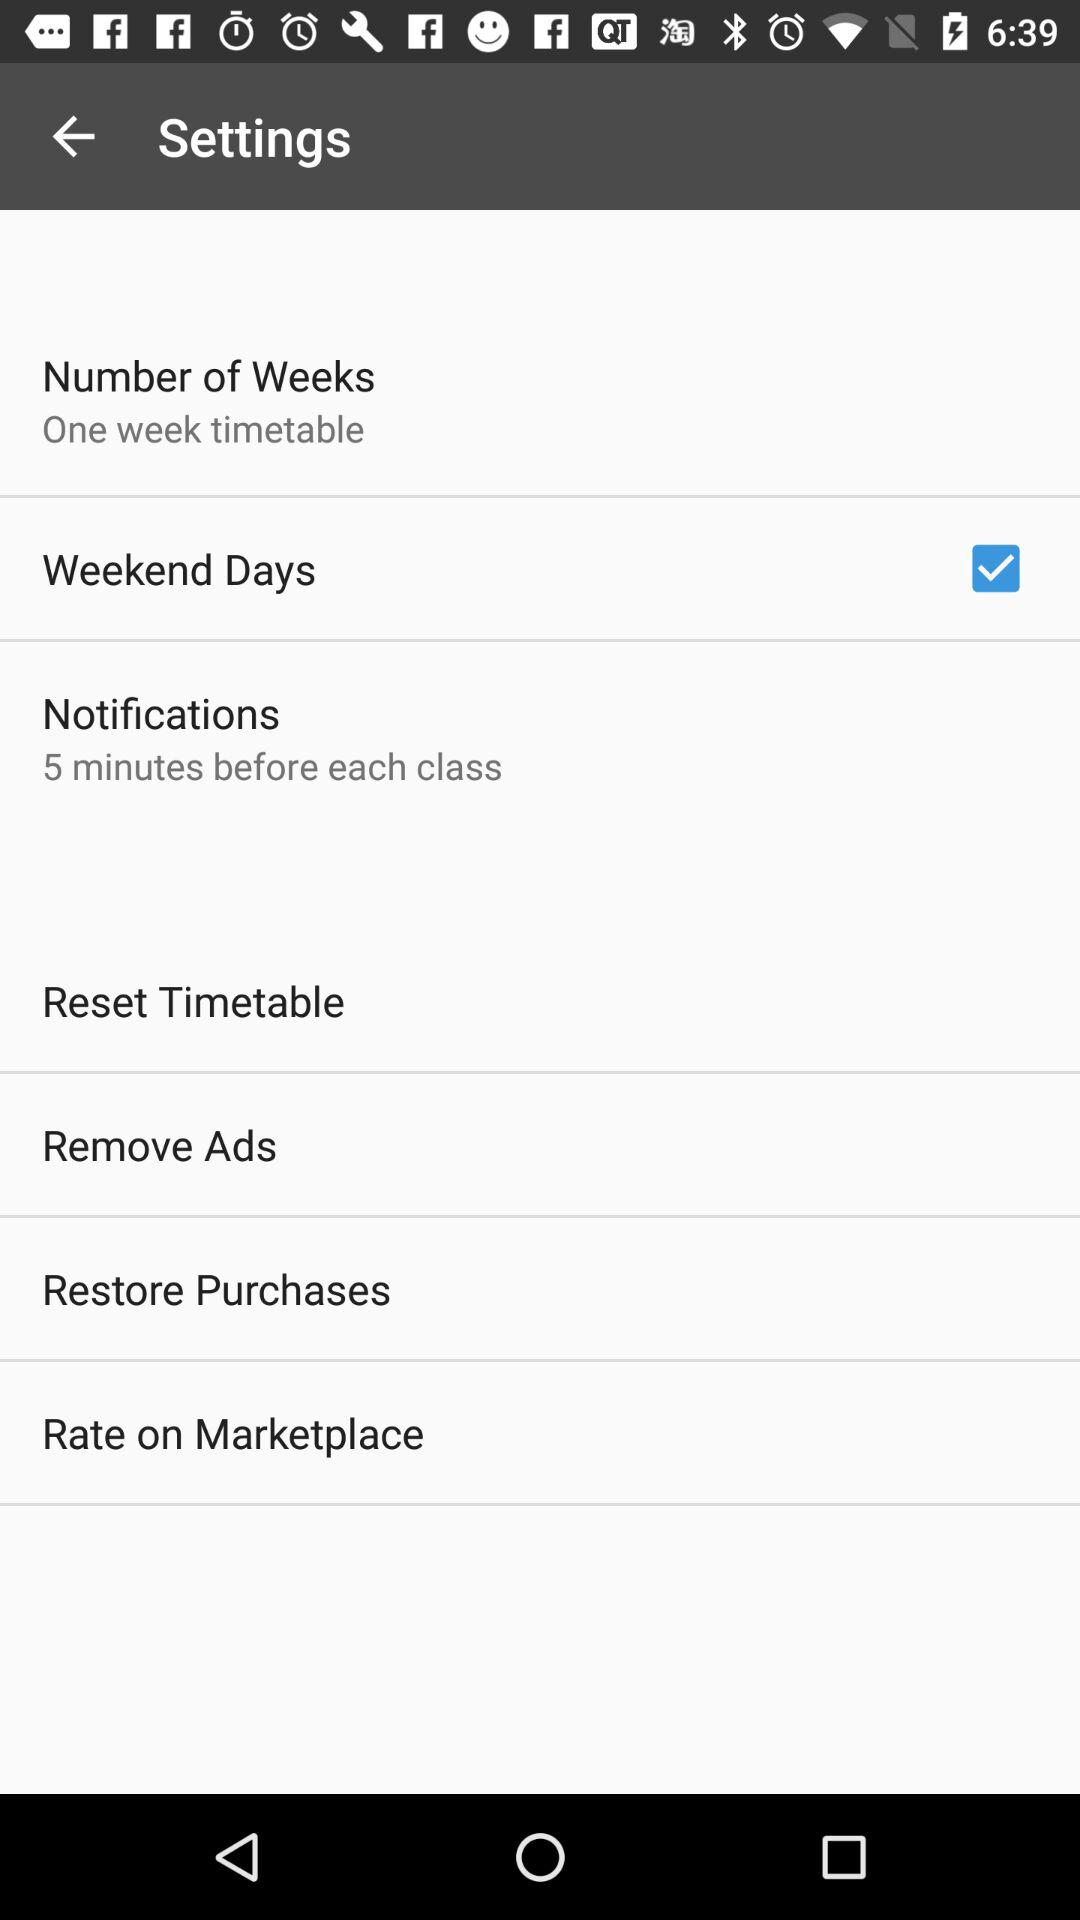Are the ads removed?
When the provided information is insufficient, respond with <no answer>. <no answer> 